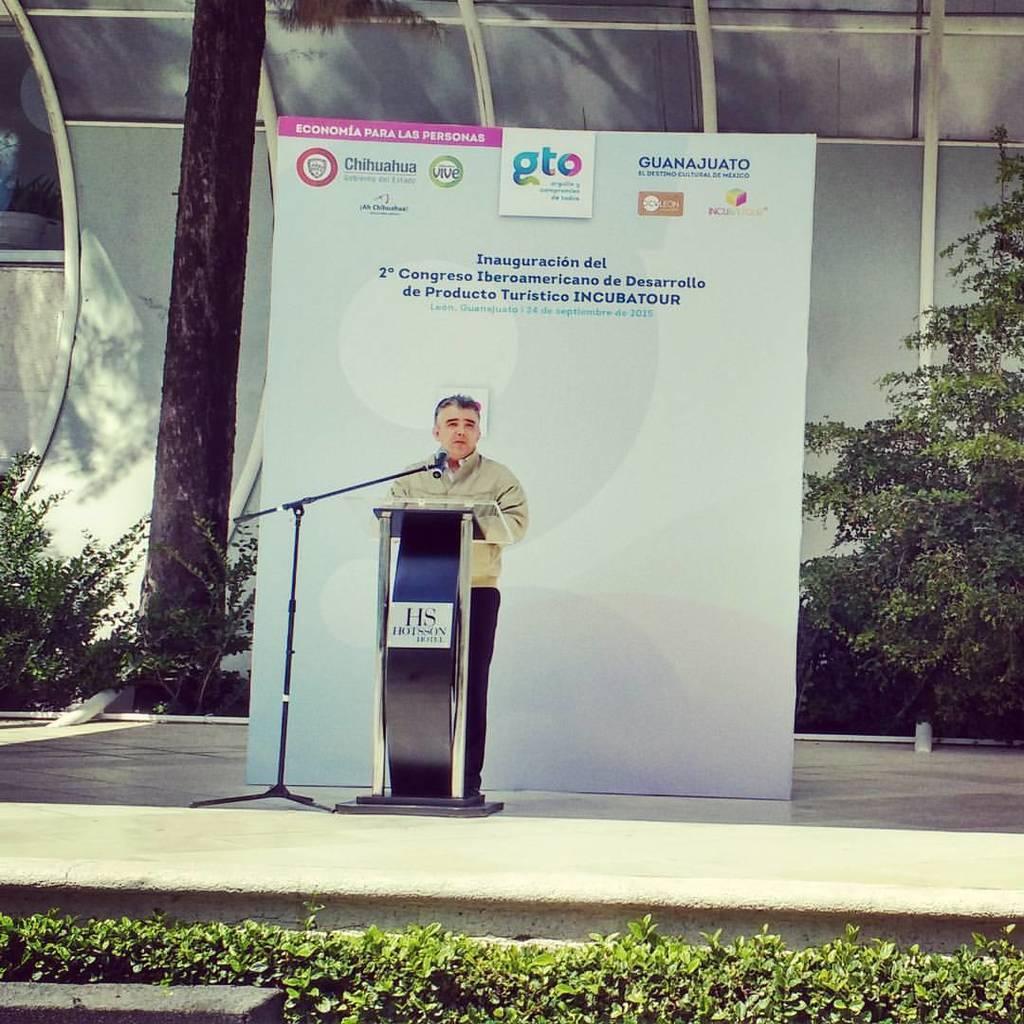Please provide a concise description of this image. In the center of the image we can see persons standing at the desk and mic. In the background we can see an advertisement, trees and building. At the bottom of the image we can see plants. 